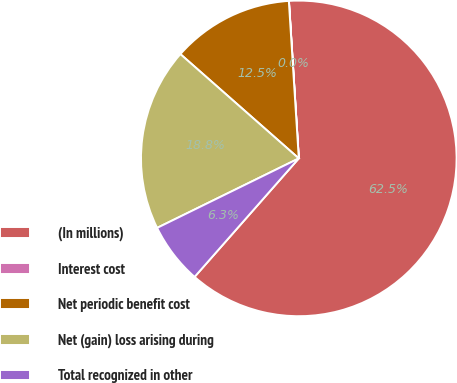<chart> <loc_0><loc_0><loc_500><loc_500><pie_chart><fcel>(In millions)<fcel>Interest cost<fcel>Net periodic benefit cost<fcel>Net (gain) loss arising during<fcel>Total recognized in other<nl><fcel>62.47%<fcel>0.01%<fcel>12.5%<fcel>18.75%<fcel>6.26%<nl></chart> 